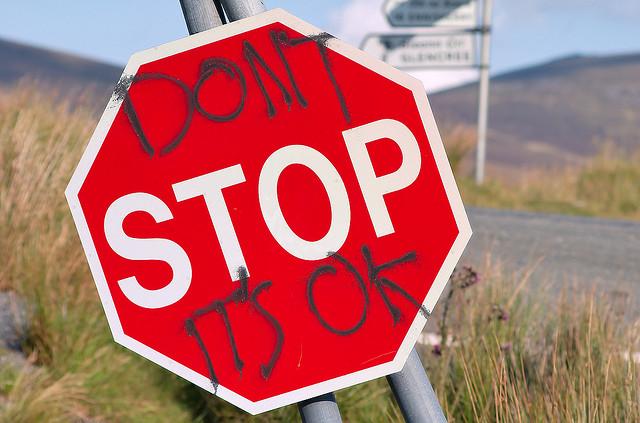What does the sign say?
Answer briefly. Don't stop it's ok. Does someone have a perspective that could be considered a bit warped?
Be succinct. Yes. Does this sign look like it originally did?
Quick response, please. No. 